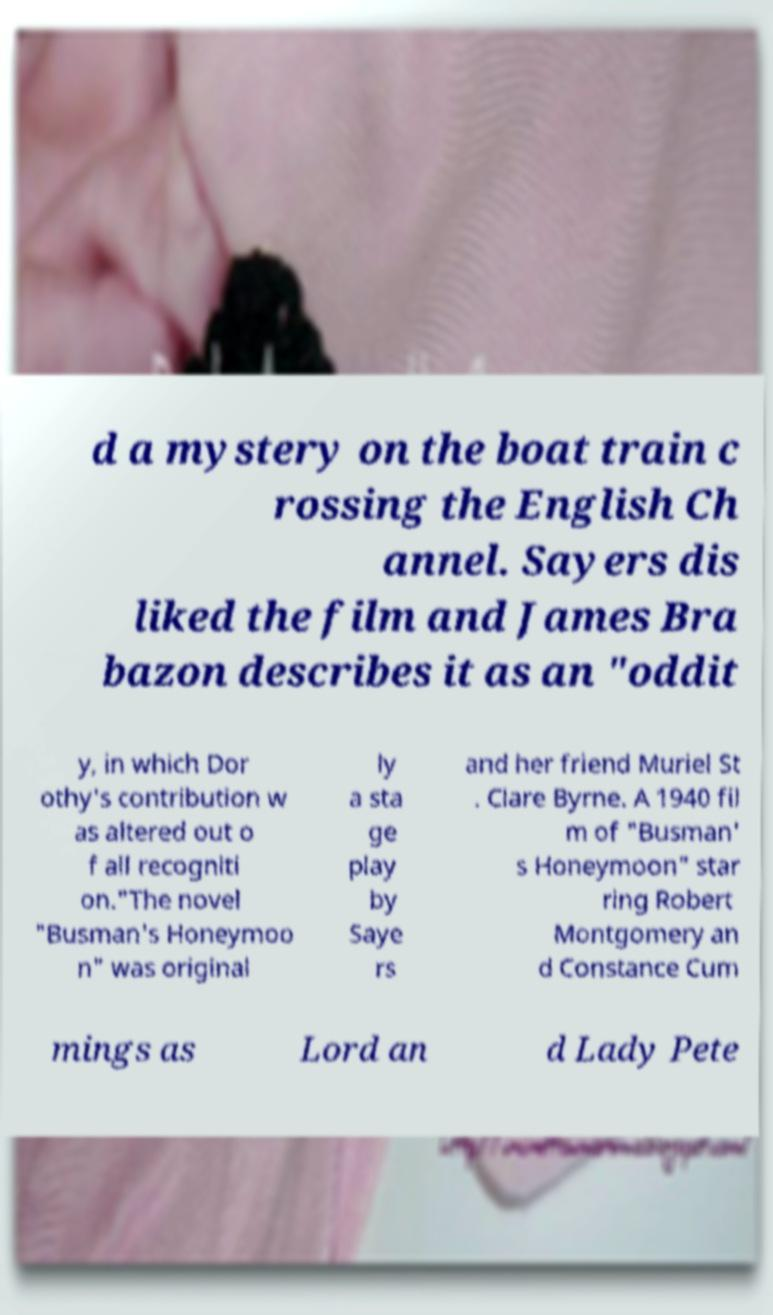Could you assist in decoding the text presented in this image and type it out clearly? d a mystery on the boat train c rossing the English Ch annel. Sayers dis liked the film and James Bra bazon describes it as an "oddit y, in which Dor othy's contribution w as altered out o f all recogniti on."The novel "Busman's Honeymoo n" was original ly a sta ge play by Saye rs and her friend Muriel St . Clare Byrne. A 1940 fil m of "Busman' s Honeymoon" star ring Robert Montgomery an d Constance Cum mings as Lord an d Lady Pete 